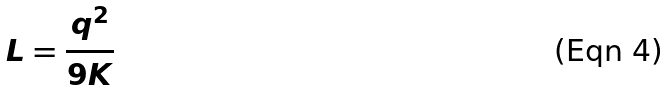<formula> <loc_0><loc_0><loc_500><loc_500>L = \frac { q ^ { 2 } } { 9 K }</formula> 